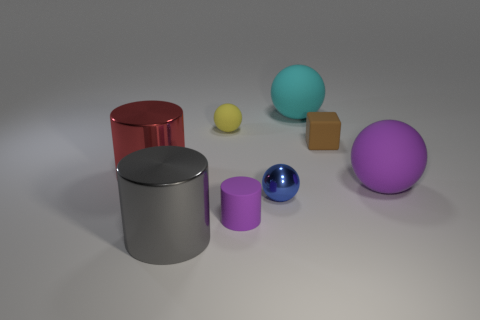There is a big sphere that is the same color as the rubber cylinder; what is its material?
Your answer should be very brief. Rubber. Are there any rubber balls of the same color as the matte cylinder?
Give a very brief answer. Yes. Is there any other thing of the same color as the tiny rubber cylinder?
Keep it short and to the point. Yes. There is a small brown rubber object; does it have the same shape as the small rubber thing that is in front of the tiny brown cube?
Offer a very short reply. No. What number of other objects are the same shape as the brown rubber thing?
Offer a very short reply. 0. What is the color of the big object that is both to the left of the cyan rubber thing and behind the purple cylinder?
Offer a very short reply. Red. The tiny cylinder has what color?
Make the answer very short. Purple. Is the material of the purple sphere the same as the small object that is behind the matte cube?
Your answer should be compact. Yes. What is the shape of the purple object that is made of the same material as the big purple sphere?
Keep it short and to the point. Cylinder. There is a matte ball that is the same size as the brown thing; what is its color?
Offer a terse response. Yellow. 